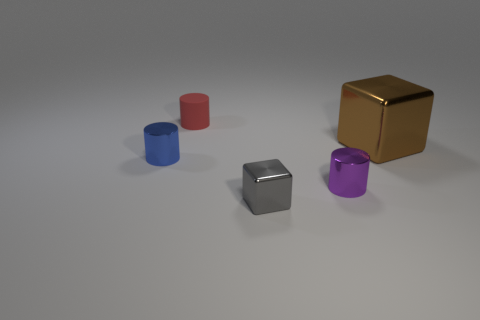How many small rubber things are the same shape as the brown metallic object?
Give a very brief answer. 0. There is a small cylinder behind the large cube; what material is it?
Offer a very short reply. Rubber. There is a object that is left of the tiny matte cylinder; is its shape the same as the tiny purple object?
Your answer should be very brief. Yes. Is there a rubber cylinder of the same size as the brown metallic block?
Provide a short and direct response. No. There is a big brown object; is it the same shape as the small rubber thing behind the small gray block?
Your response must be concise. No. Is the number of small red cylinders that are in front of the gray cube less than the number of large brown things?
Offer a terse response. Yes. Is the shape of the big brown thing the same as the gray metallic object?
Keep it short and to the point. Yes. What is the size of the brown cube that is made of the same material as the blue object?
Your answer should be very brief. Large. Is the number of blue matte objects less than the number of tiny rubber cylinders?
Give a very brief answer. Yes. What number of small things are either purple cylinders or gray things?
Your answer should be compact. 2. 